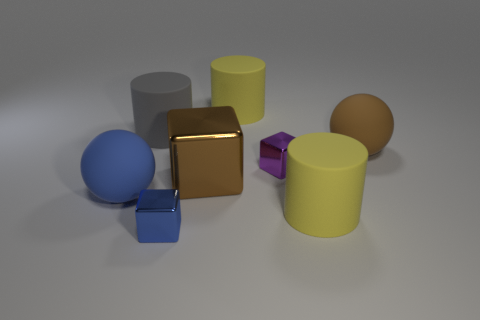Subtract all brown metallic cubes. How many cubes are left? 2 Subtract all purple cubes. How many yellow cylinders are left? 2 Add 1 tiny yellow cylinders. How many objects exist? 9 Subtract 1 blocks. How many blocks are left? 2 Subtract 1 yellow cylinders. How many objects are left? 7 Subtract all spheres. How many objects are left? 6 Subtract all gray cylinders. Subtract all gray cubes. How many cylinders are left? 2 Subtract all brown metallic things. Subtract all blue rubber balls. How many objects are left? 6 Add 4 tiny blue things. How many tiny blue things are left? 5 Add 7 red things. How many red things exist? 7 